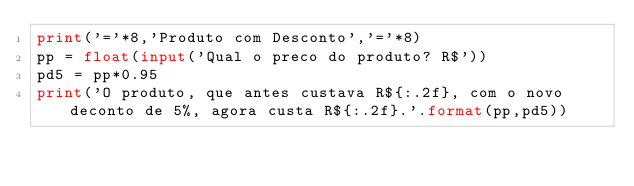<code> <loc_0><loc_0><loc_500><loc_500><_Python_>print('='*8,'Produto com Desconto','='*8)
pp = float(input('Qual o preco do produto? R$'))
pd5 = pp*0.95
print('O produto, que antes custava R${:.2f}, com o novo deconto de 5%, agora custa R${:.2f}.'.format(pp,pd5))
</code> 